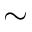Convert formula to latex. <formula><loc_0><loc_0><loc_500><loc_500>\sim</formula> 